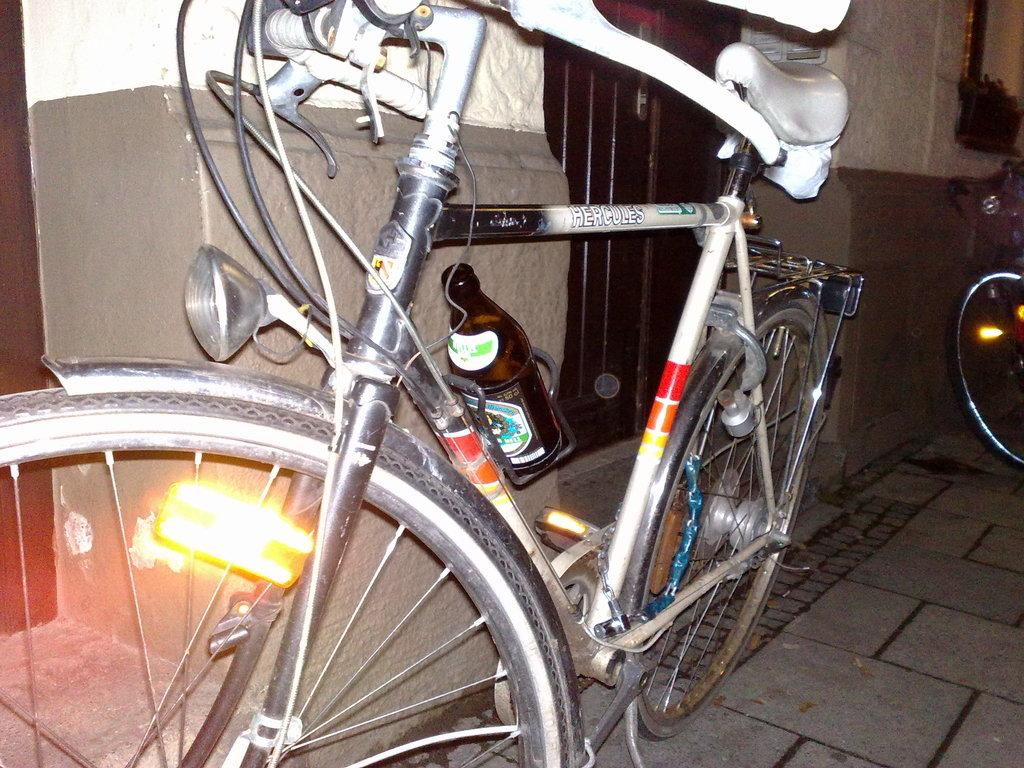What objects are on the floor in the image? There are bicycles on the floor in the image. What can be seen in the background of the image? There is a window and a wall in the background of the image. What is attached to one of the bicycles? A bottle is attached to one of the bicycles. What type of alarm is going off in the image? There is no alarm present in the image. How does the digestion process of the bicycles appear in the image? Bicycles do not have a digestion process, as they are inanimate objects. 